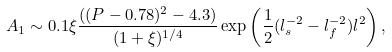Convert formula to latex. <formula><loc_0><loc_0><loc_500><loc_500>A _ { 1 } \sim 0 . 1 \xi \frac { ( ( P - 0 . 7 8 ) ^ { 2 } - 4 . 3 ) } { ( 1 + \xi ) ^ { 1 / 4 } } \exp \left ( \frac { 1 } { 2 } ( l _ { s } ^ { - 2 } - l _ { f } ^ { - 2 } ) l ^ { 2 } \right ) ,</formula> 